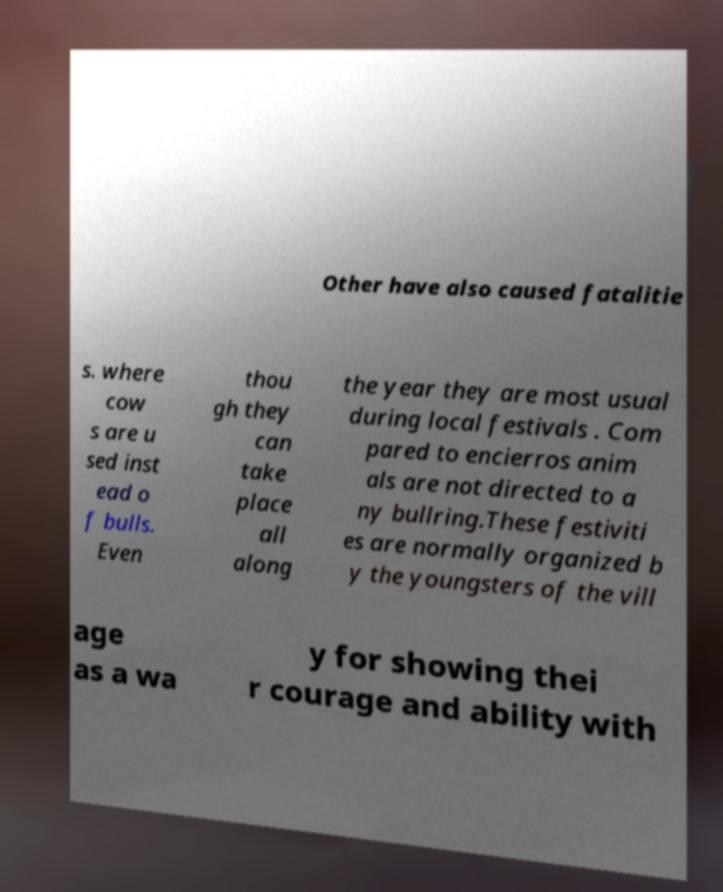What messages or text are displayed in this image? I need them in a readable, typed format. Other have also caused fatalitie s. where cow s are u sed inst ead o f bulls. Even thou gh they can take place all along the year they are most usual during local festivals . Com pared to encierros anim als are not directed to a ny bullring.These festiviti es are normally organized b y the youngsters of the vill age as a wa y for showing thei r courage and ability with 